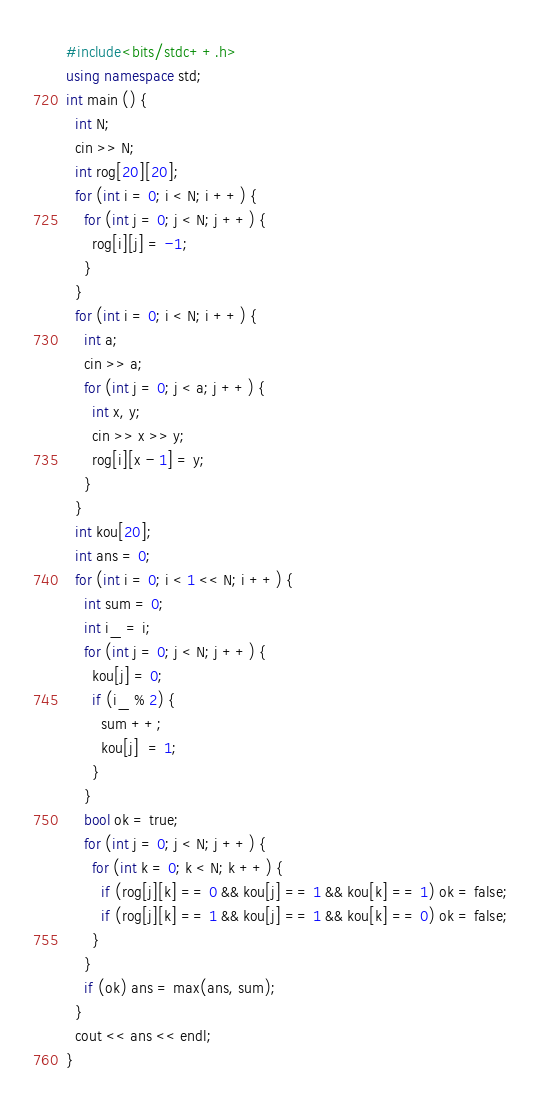Convert code to text. <code><loc_0><loc_0><loc_500><loc_500><_C++_>#include<bits/stdc++.h>
using namespace std;
int main () {
  int N;
  cin >> N;
  int rog[20][20];
  for (int i = 0; i < N; i ++) {
    for (int j = 0; j < N; j ++) {
      rog[i][j] = -1;
    }
  }
  for (int i = 0; i < N; i ++) {
    int a;
    cin >> a;
    for (int j = 0; j < a; j ++) {
      int x, y;
      cin >> x >> y;
      rog[i][x - 1] = y;
    }
  }
  int kou[20];
  int ans = 0;
  for (int i = 0; i < 1 << N; i ++) {
    int sum = 0;
    int i_ = i;
    for (int j = 0; j < N; j ++) {
      kou[j] = 0;
      if (i_ % 2) {
        sum ++;
        kou[j]  = 1;
      }
    }
    bool ok = true;
    for (int j = 0; j < N; j ++) {
      for (int k = 0; k < N; k ++) {
        if (rog[j][k] == 0 && kou[j] == 1 && kou[k] == 1) ok = false;
        if (rog[j][k] == 1 && kou[j] == 1 && kou[k] == 0) ok = false;
      }
    }
    if (ok) ans = max(ans, sum);
  }
  cout << ans << endl;
}</code> 